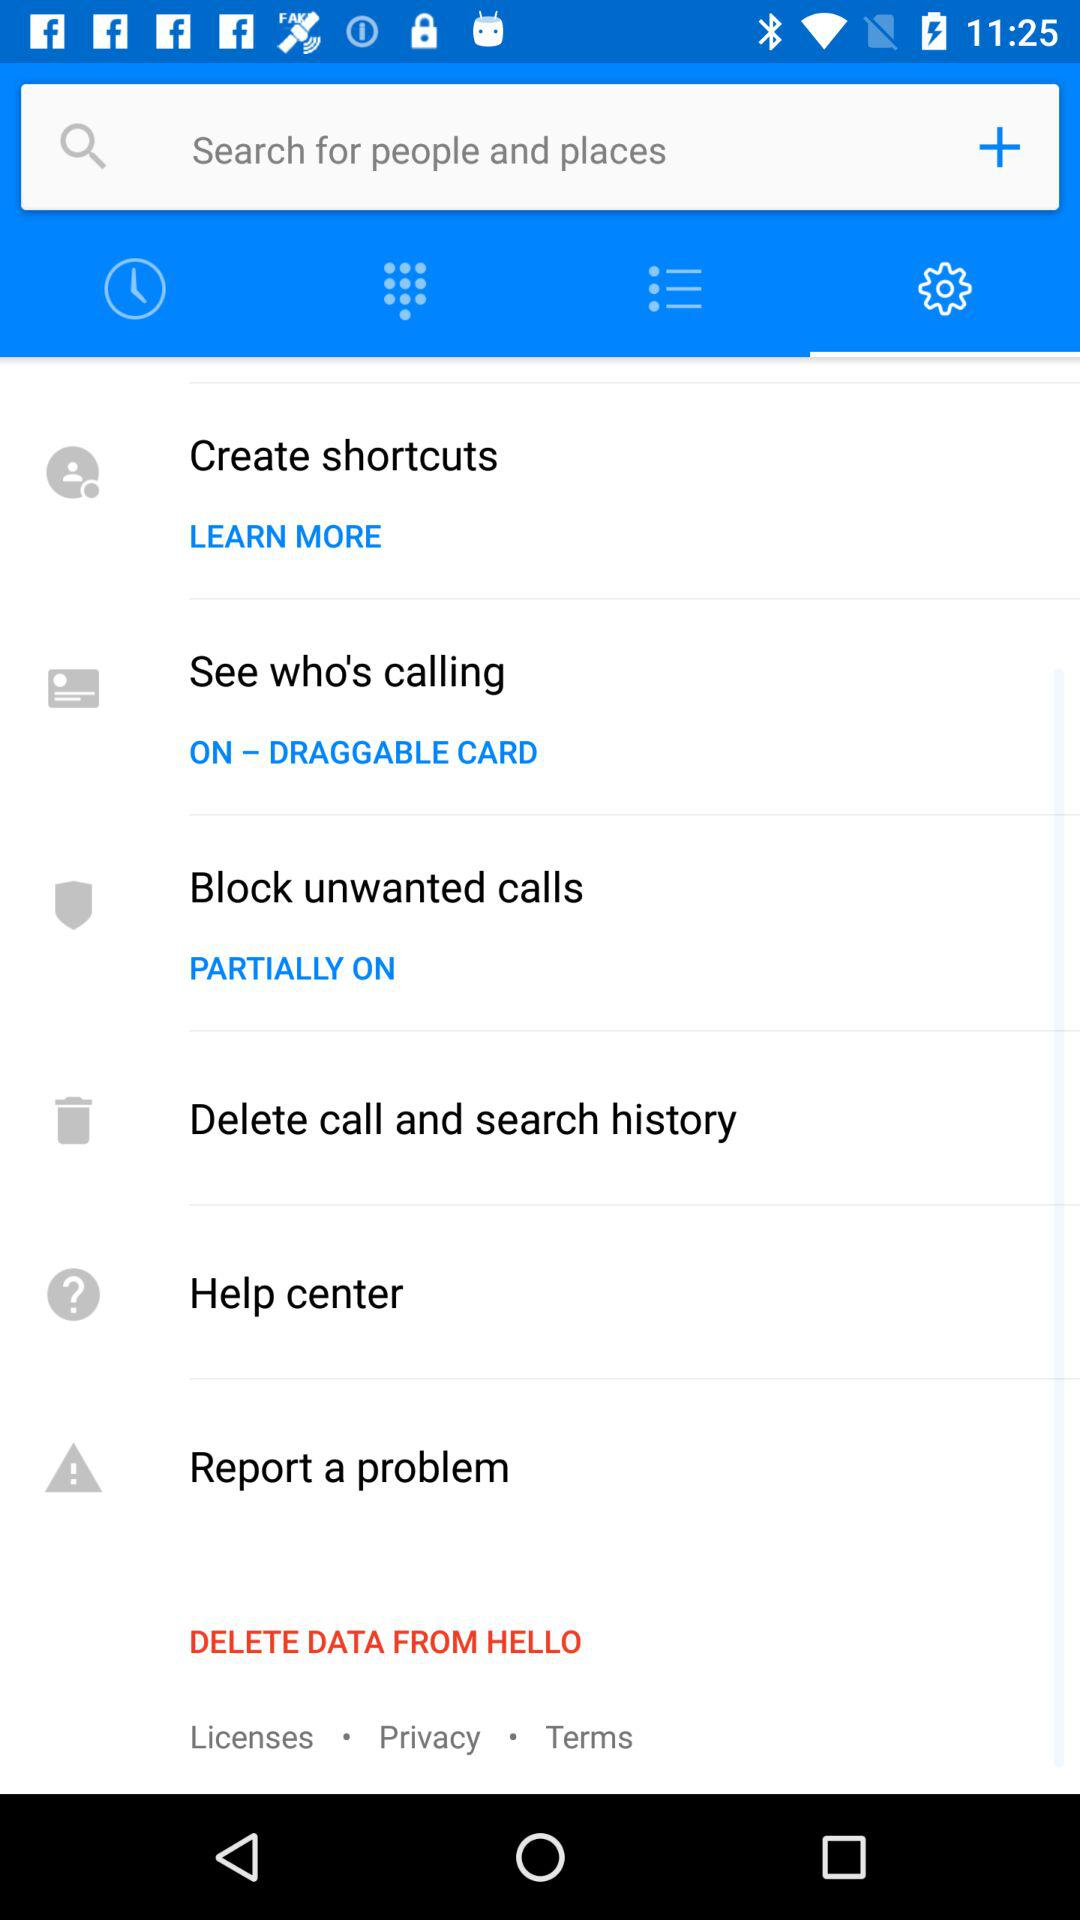What's the status of "Block unwanted calls"? The status is "PARTIALLY ON". 